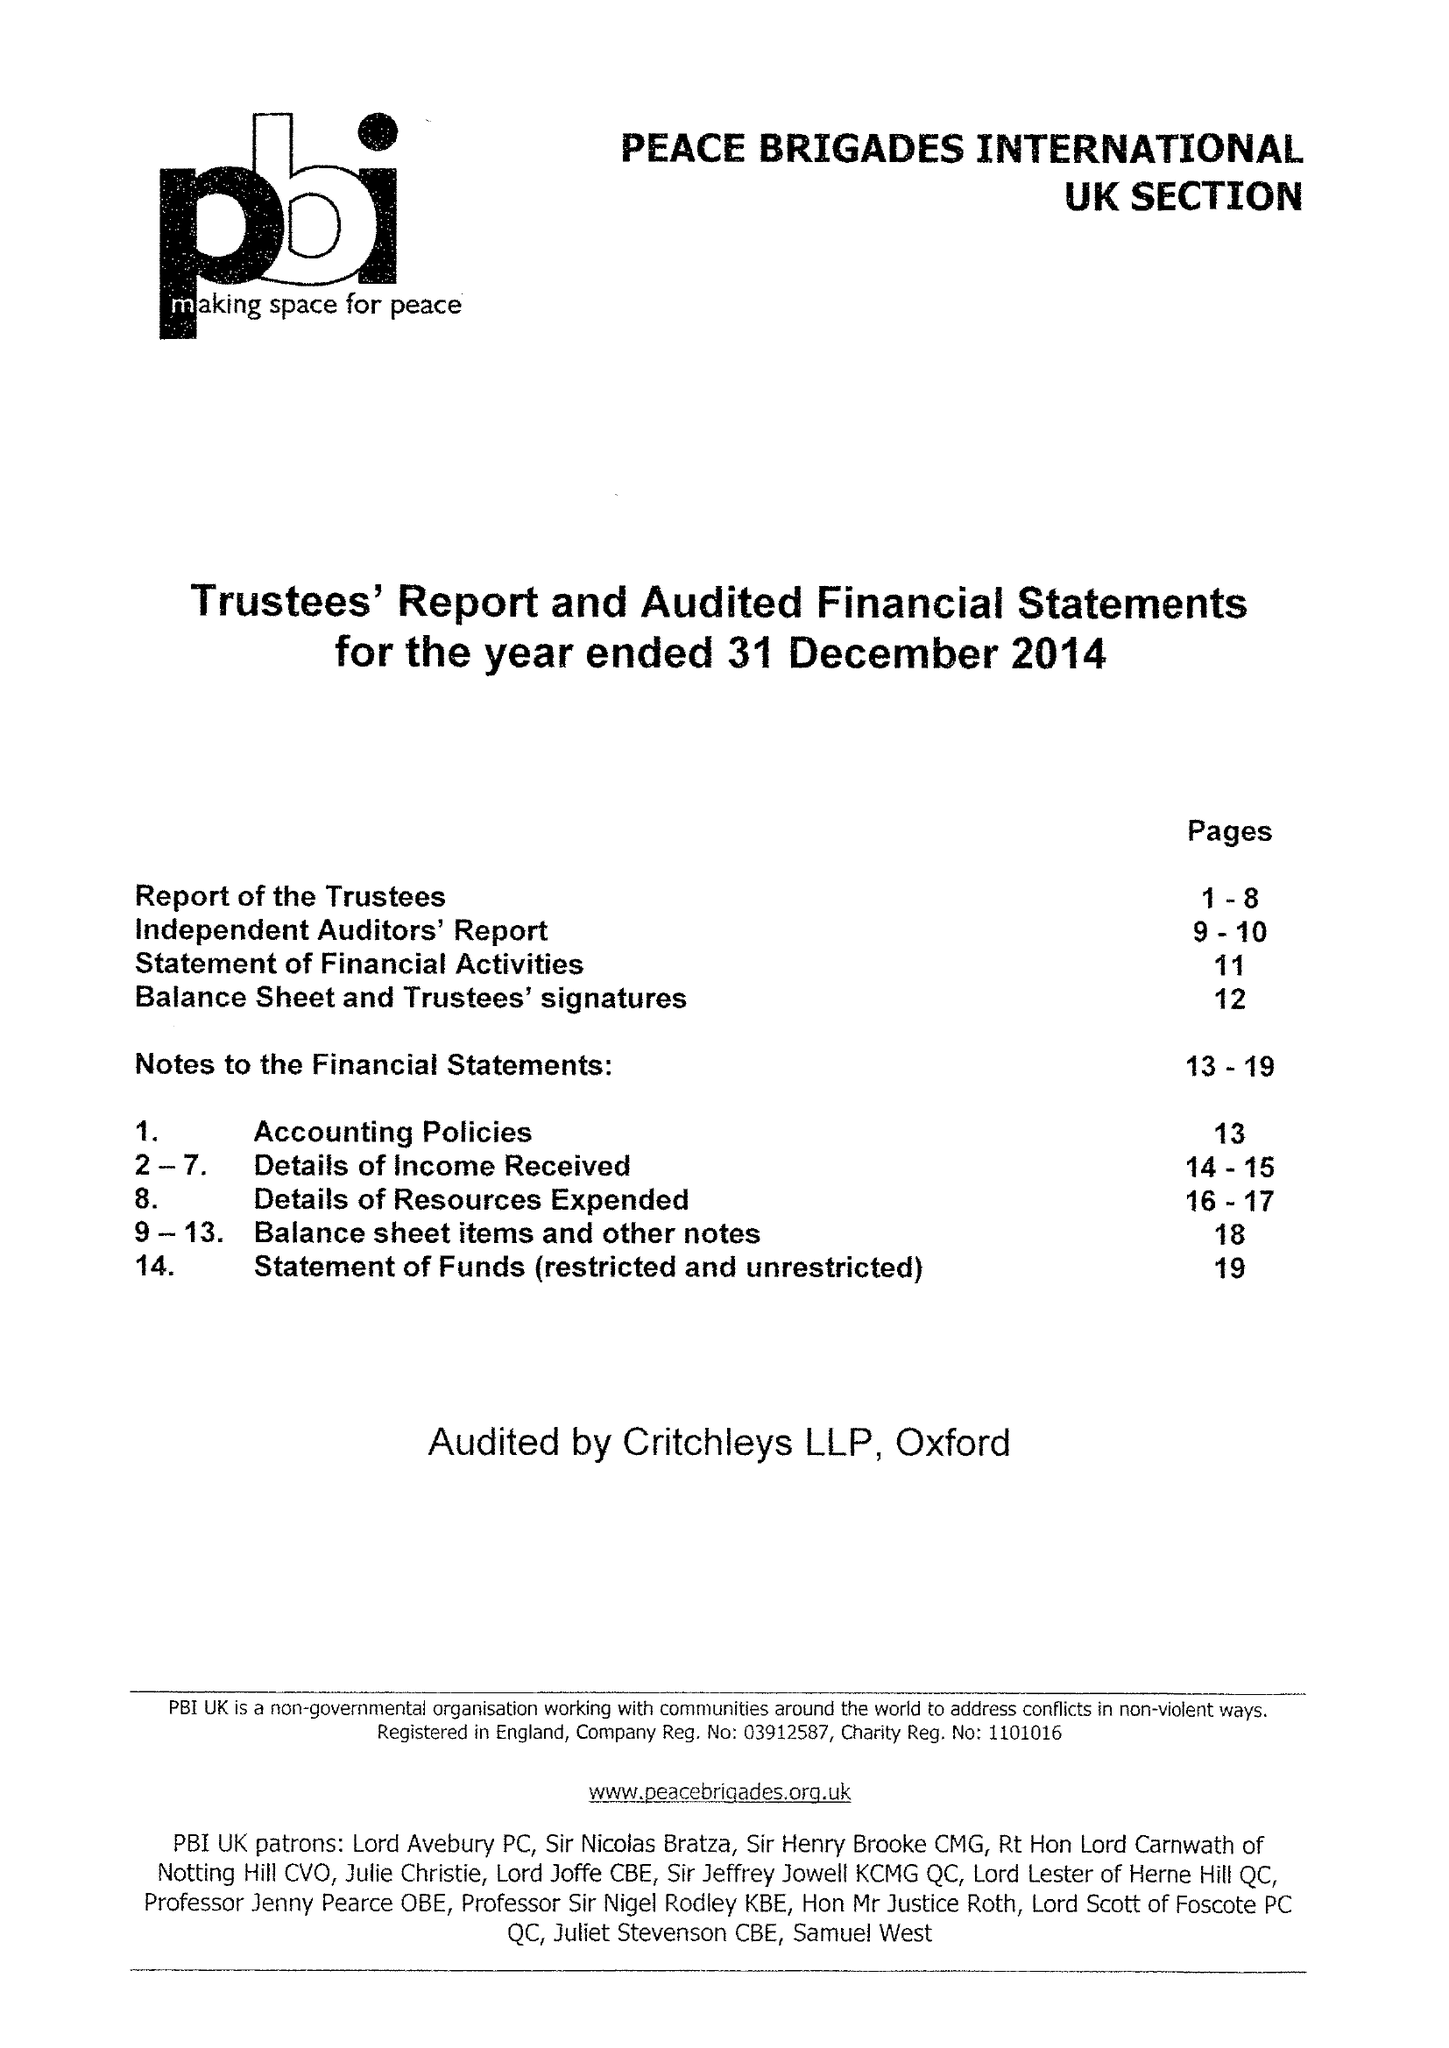What is the value for the spending_annually_in_british_pounds?
Answer the question using a single word or phrase. 305286.00 